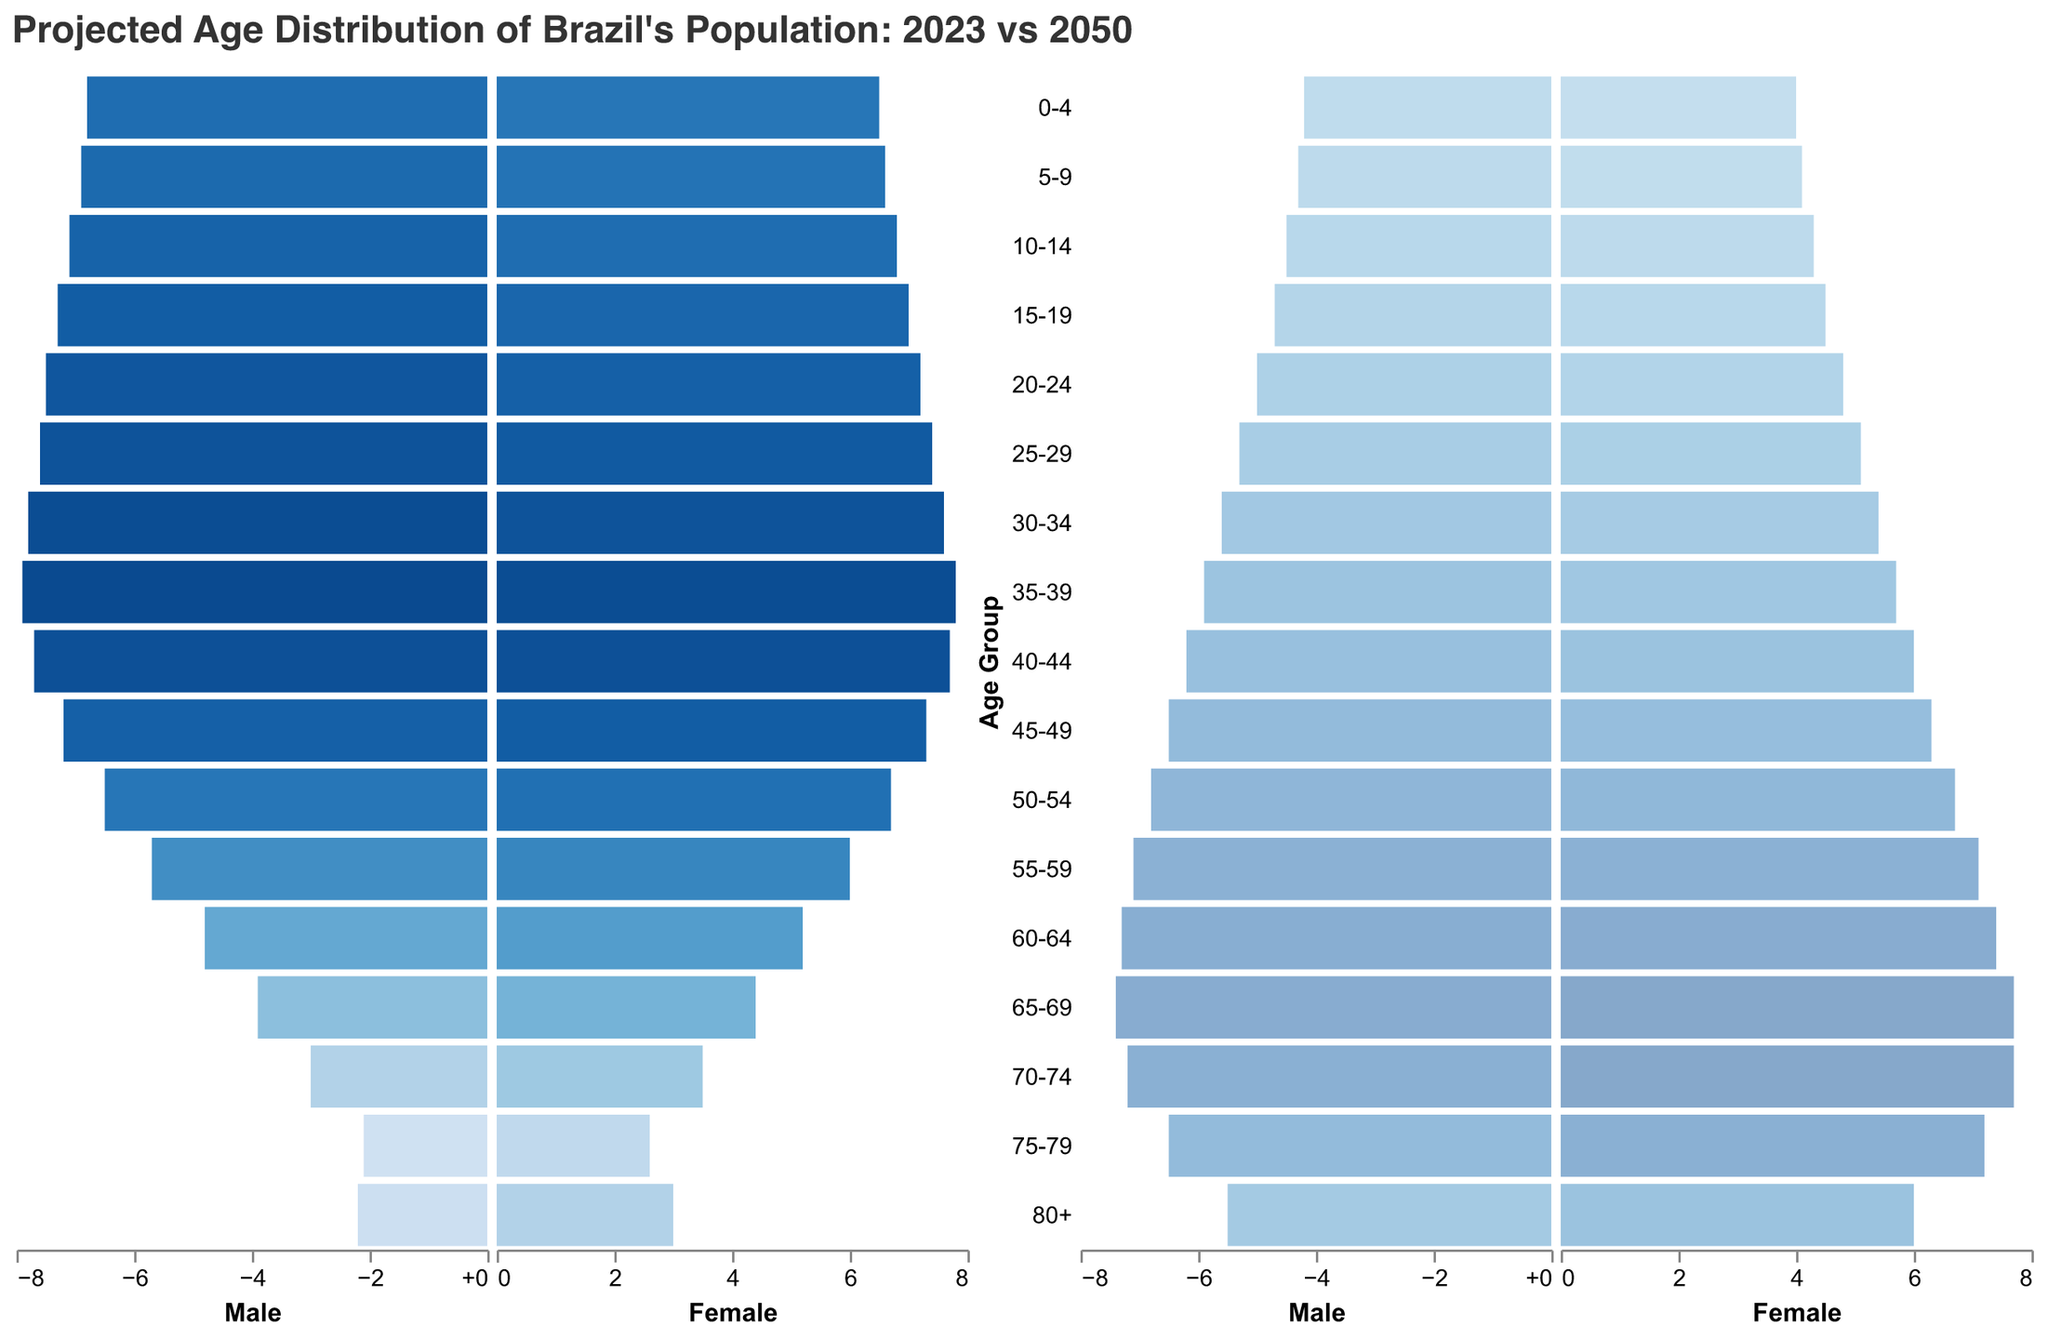What is the title of the figure? The title is usually located at the top center of the plot and it summarizes the main theme of the chart. The title of this figure is "Projected Age Distribution of Brazil's Population: 2023 vs 2050".
Answer: Projected Age Distribution of Brazil's Population: 2023 vs 2050 How many age groups are shown in the figure? The age groups are shown as categories along the y-axis. There are 17 age groups listed from "0-4" to "80+".
Answer: 17 Which age group has the highest percentage of males in 2023? To find the highest percentage of males in 2023, look at the leftmost section of the plot for the tallest bar among the "Male 2023" data. The tallest bar is in the "35-39" age group with 7.9%.
Answer: 35-39 Which age group has the lowest percentage of females in 2050? To find the lowest percentage of females in 2050, look at the rightmost section of the plot for the shortest bar among the "Female 2050" data. The shortest bar is in the "0-4" age group with 4.0%.
Answer: 0-4 How does the percentage of the "60-64" age group change from 2023 to 2050 for males? Compare the bars for the "60-64" age group. For males, the percentage increases from 4.8% in 2023 to 7.3% in 2050.
Answer: Increases from 4.8% to 7.3% What is the combined percentage of females in the "70-74" age group for both 2023 and 2050? Add the percentages for females in the "70-74" age group in both years. It is 3.5% in 2023 and 7.7% in 2050, so 3.5 + 7.7 = 11.2%.
Answer: 11.2% Which age group shows the greatest increase in the male population percentage from 2023 to 2050? Compare the differences in percentages for all age groups for males from 2023 to 2050. The "70-74" age group shows the greatest increase, from 3.0% in 2023 to 7.2% in 2050, which is an increase of 4.2%.
Answer: 70-74 Are there any age groups where the percentage of both males and females decreases from 2023 to 2050? Look for the age groups where both male and female percentages are lower in 2050 compared to 2023. All age groups from "0-4" to "35-39" show a decrease in percentages for both genders.
Answer: 0-4 to 35-39 What is the percentage of males in the "50-54" age group in 2023, and how does it compare to females in the same age group in 2050? The percentage of males in the "50-54" age group in 2023 is 6.5%. For females in the same age group in 2050, it is 6.7%. Compare these values to see that the percentage for females is slightly higher.
Answer: 6.5% (Male 2023), 6.7% (Female 2050) What trends can be observed for the "80+" age group from 2023 to 2050 for both genders? Observe the bars for the "80+" age group. For males, the percentage increases from 2.2% in 2023 to 5.5% in 2050. For females, it increases from 3.0% in 2023 to 6.0% in 2050. Both have a noticeable increase.
Answer: Increase for both genders 